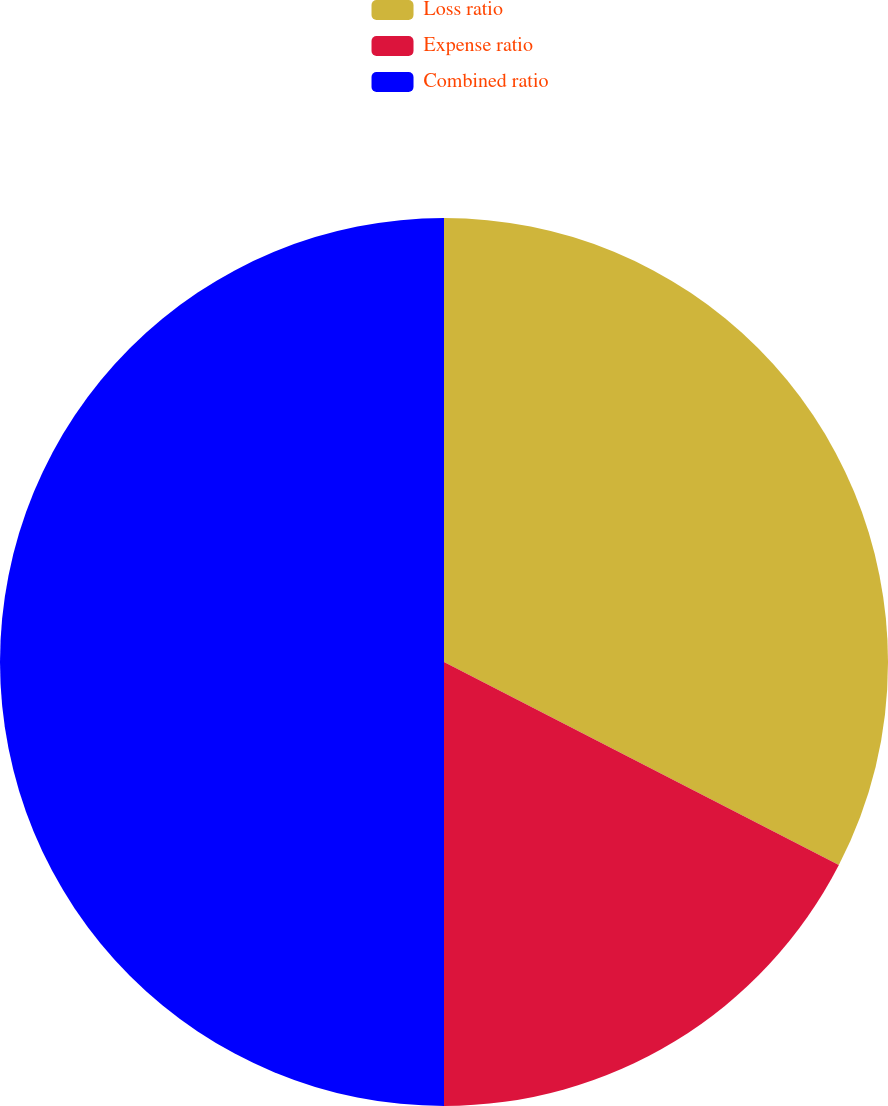Convert chart. <chart><loc_0><loc_0><loc_500><loc_500><pie_chart><fcel>Loss ratio<fcel>Expense ratio<fcel>Combined ratio<nl><fcel>32.56%<fcel>17.44%<fcel>50.0%<nl></chart> 